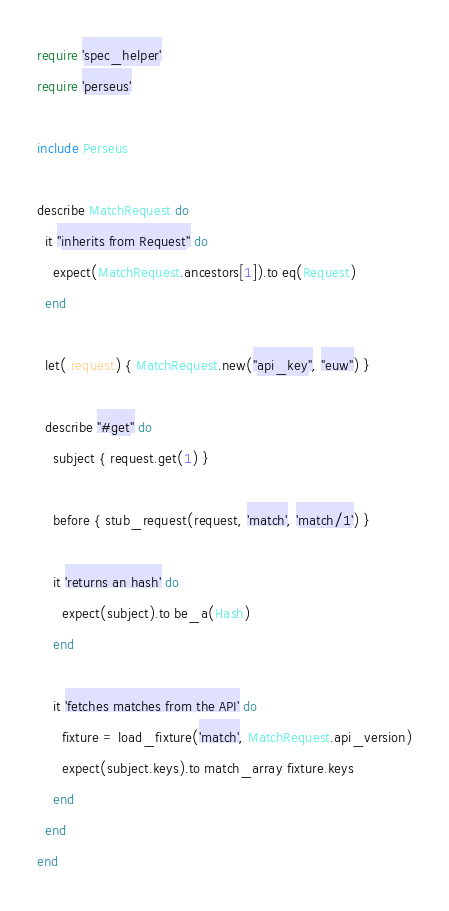Convert code to text. <code><loc_0><loc_0><loc_500><loc_500><_Ruby_>require 'spec_helper'
require 'perseus'

include Perseus

describe MatchRequest do
  it "inherits from Request" do
    expect(MatchRequest.ancestors[1]).to eq(Request)
  end

  let(:request) { MatchRequest.new("api_key", "euw") }

  describe "#get" do
    subject { request.get(1) }

    before { stub_request(request, 'match', 'match/1') }

    it 'returns an hash' do
      expect(subject).to be_a(Hash)
    end

    it 'fetches matches from the API' do
      fixture = load_fixture('match', MatchRequest.api_version)
      expect(subject.keys).to match_array fixture.keys
    end
  end
end
</code> 